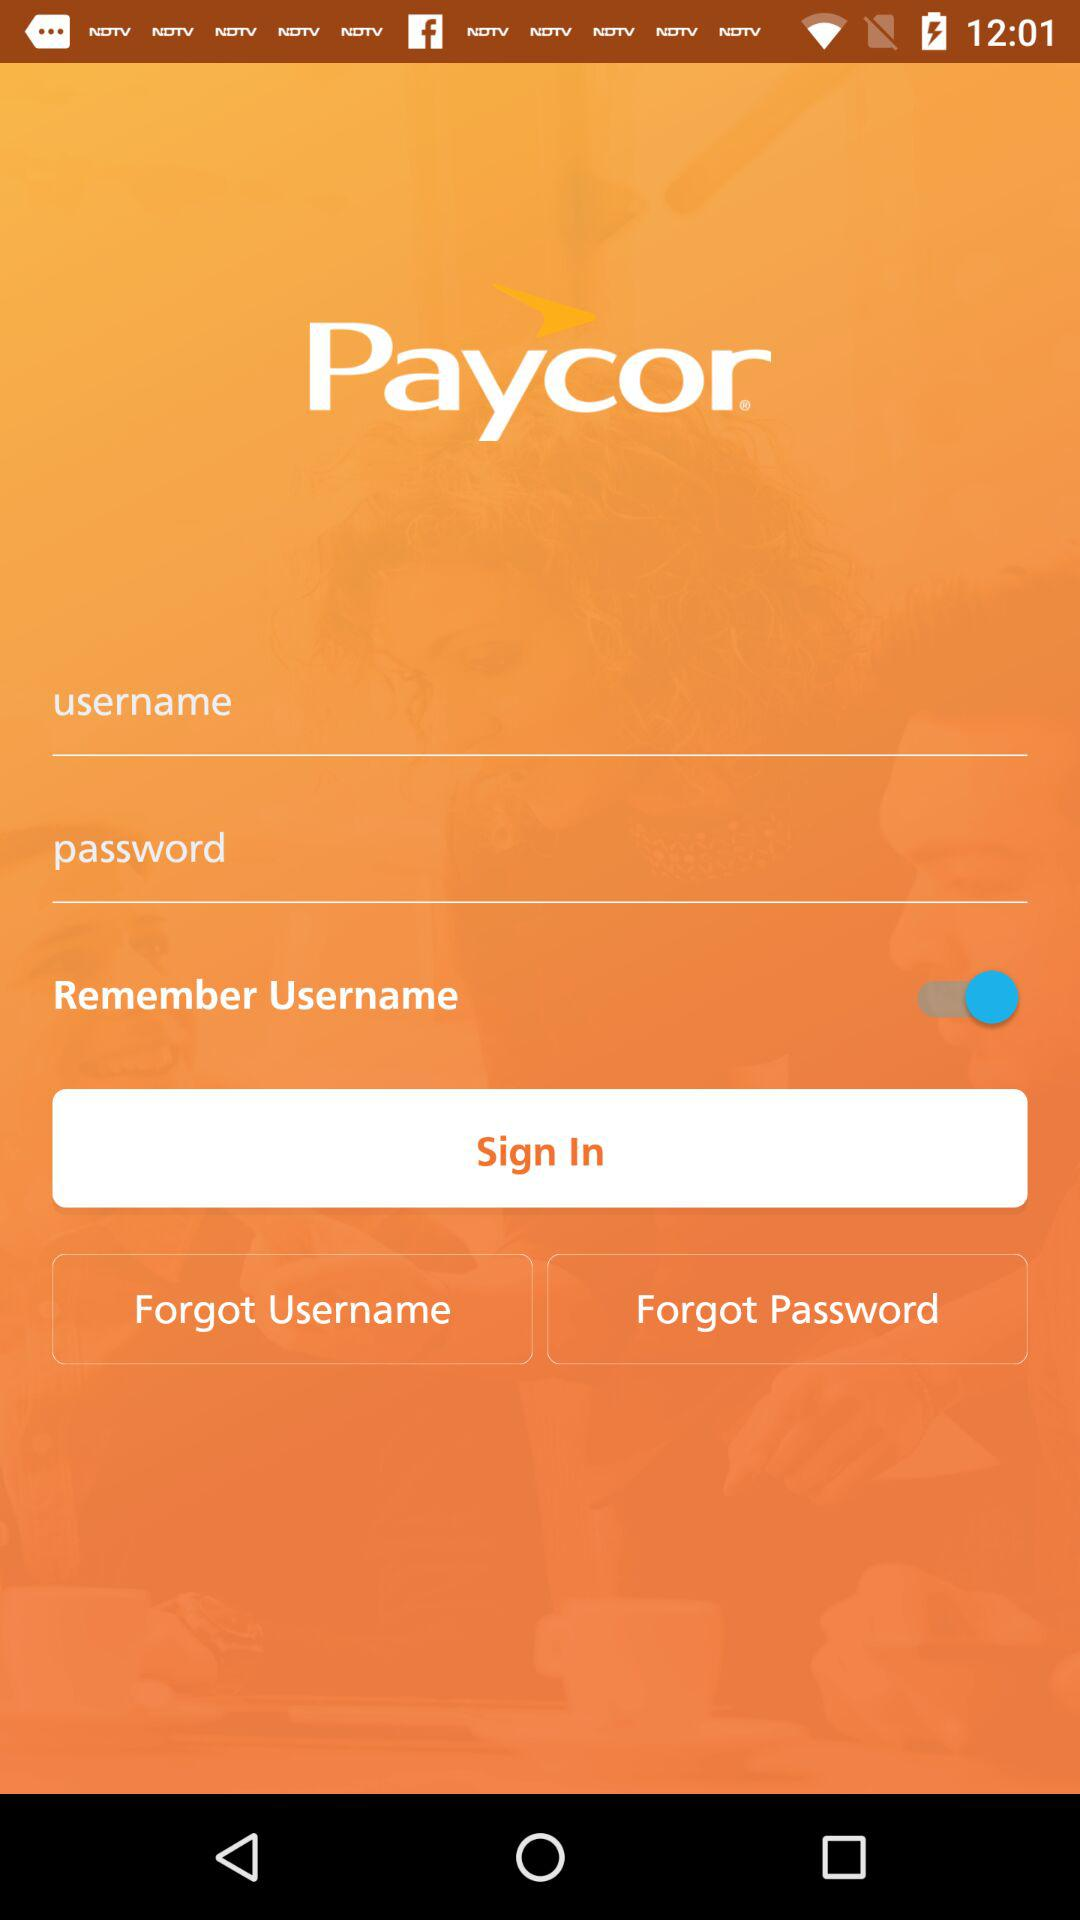What is the application name? The application name is "Paycor". 